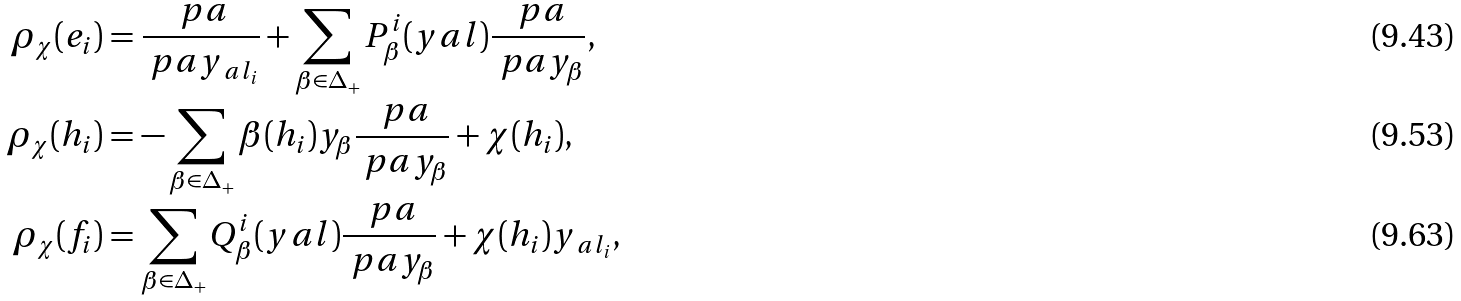Convert formula to latex. <formula><loc_0><loc_0><loc_500><loc_500>\rho _ { \chi } ( e _ { i } ) & = \frac { \ p a } { \ p a y _ { \ a l _ { i } } } + \sum _ { \beta \in \Delta _ { + } } P ^ { i } _ { \beta } ( y _ { \ } a l ) \frac { \ p a } { \ p a y _ { \beta } } , \\ \rho _ { \chi } ( h _ { i } ) & = - \sum _ { \beta \in \Delta _ { + } } \beta ( h _ { i } ) y _ { \beta } \frac { \ p a } { \ p a y _ { \beta } } + \chi ( h _ { i } ) , \\ \rho _ { \chi } ( f _ { i } ) & = \sum _ { \beta \in \Delta _ { + } } Q ^ { i } _ { \beta } ( y _ { \ } a l ) \frac { \ p a } { \ p a y _ { \beta } } + \chi ( h _ { i } ) y _ { \ a l _ { i } } ,</formula> 